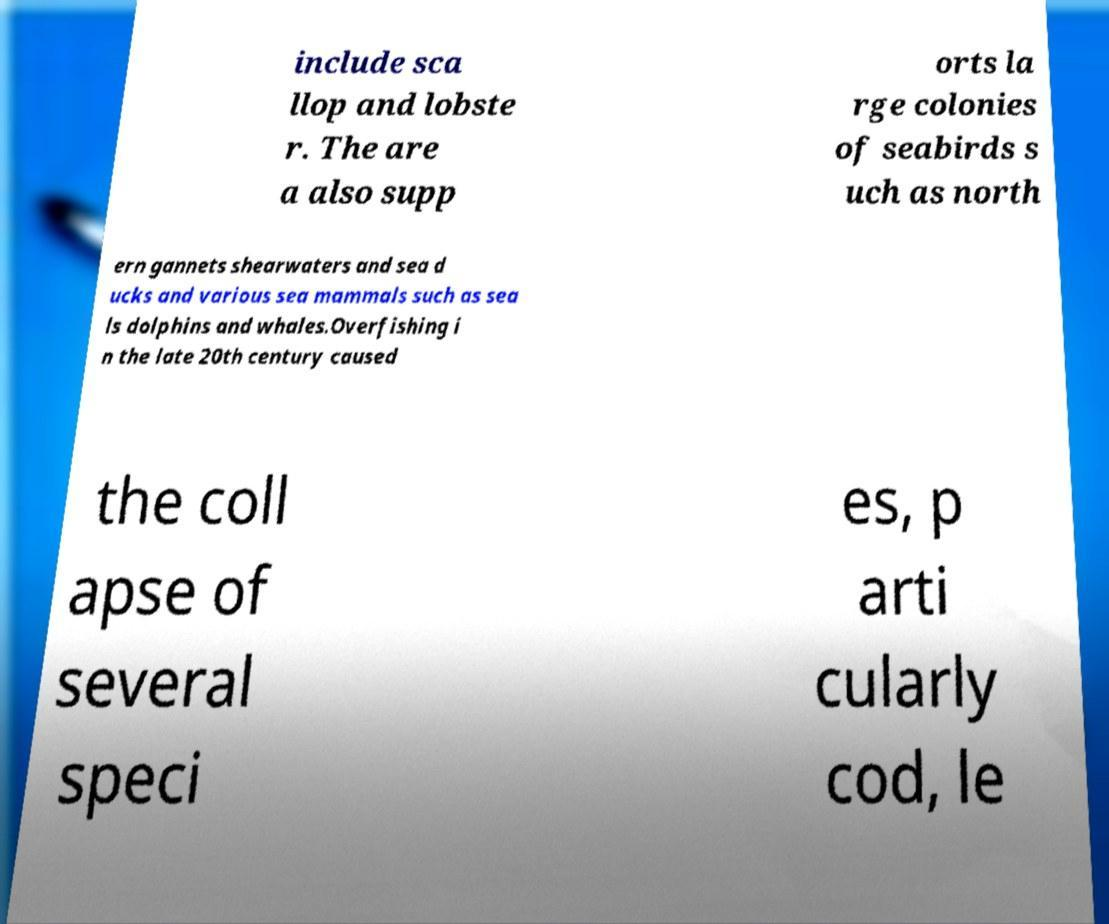Could you assist in decoding the text presented in this image and type it out clearly? include sca llop and lobste r. The are a also supp orts la rge colonies of seabirds s uch as north ern gannets shearwaters and sea d ucks and various sea mammals such as sea ls dolphins and whales.Overfishing i n the late 20th century caused the coll apse of several speci es, p arti cularly cod, le 